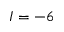<formula> <loc_0><loc_0><loc_500><loc_500>I = - 6</formula> 